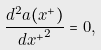<formula> <loc_0><loc_0><loc_500><loc_500>\frac { d ^ { 2 } a ( x ^ { + } ) } { { d x ^ { + } } ^ { 2 } } = 0 ,</formula> 